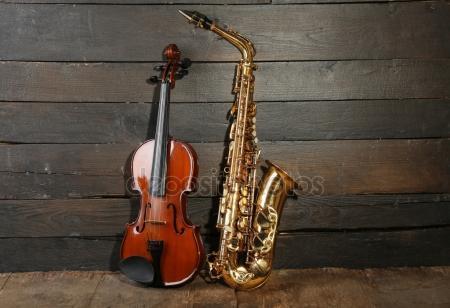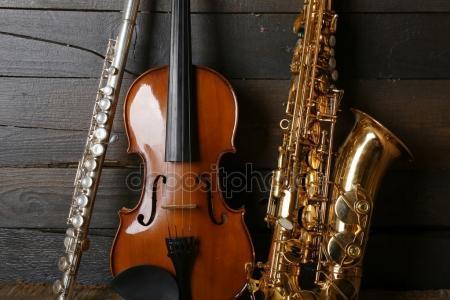The first image is the image on the left, the second image is the image on the right. Assess this claim about the two images: "An image shows a guitar, a gold saxophone, and a silver clarinet, all standing upright side-by-side.". Correct or not? Answer yes or no. Yes. The first image is the image on the left, the second image is the image on the right. For the images shown, is this caption "A saxophone stands alone in the image on the left." true? Answer yes or no. No. 